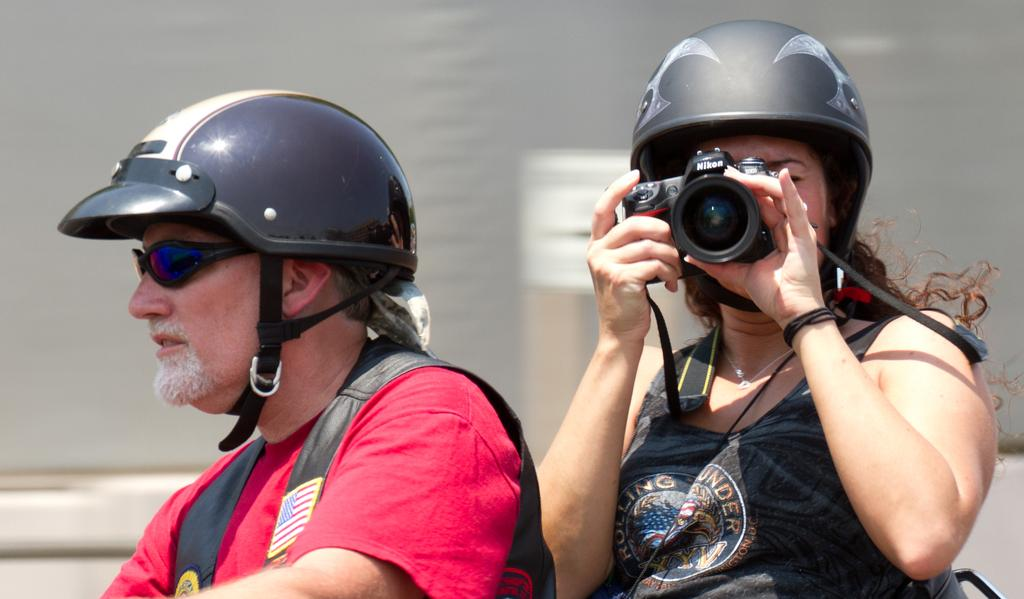How many persons are in the image? There are two persons in the image. What are the persons wearing on their heads? Both persons are wearing helmets. What is the person on the right side of the image holding? The person on the right side of the image is holding a camera in her hand. Can you see any ants crawling on the helmets in the image? There are no ants visible in the image. What type of sponge is being used by the persons in the image? There is no sponge present in the image. 